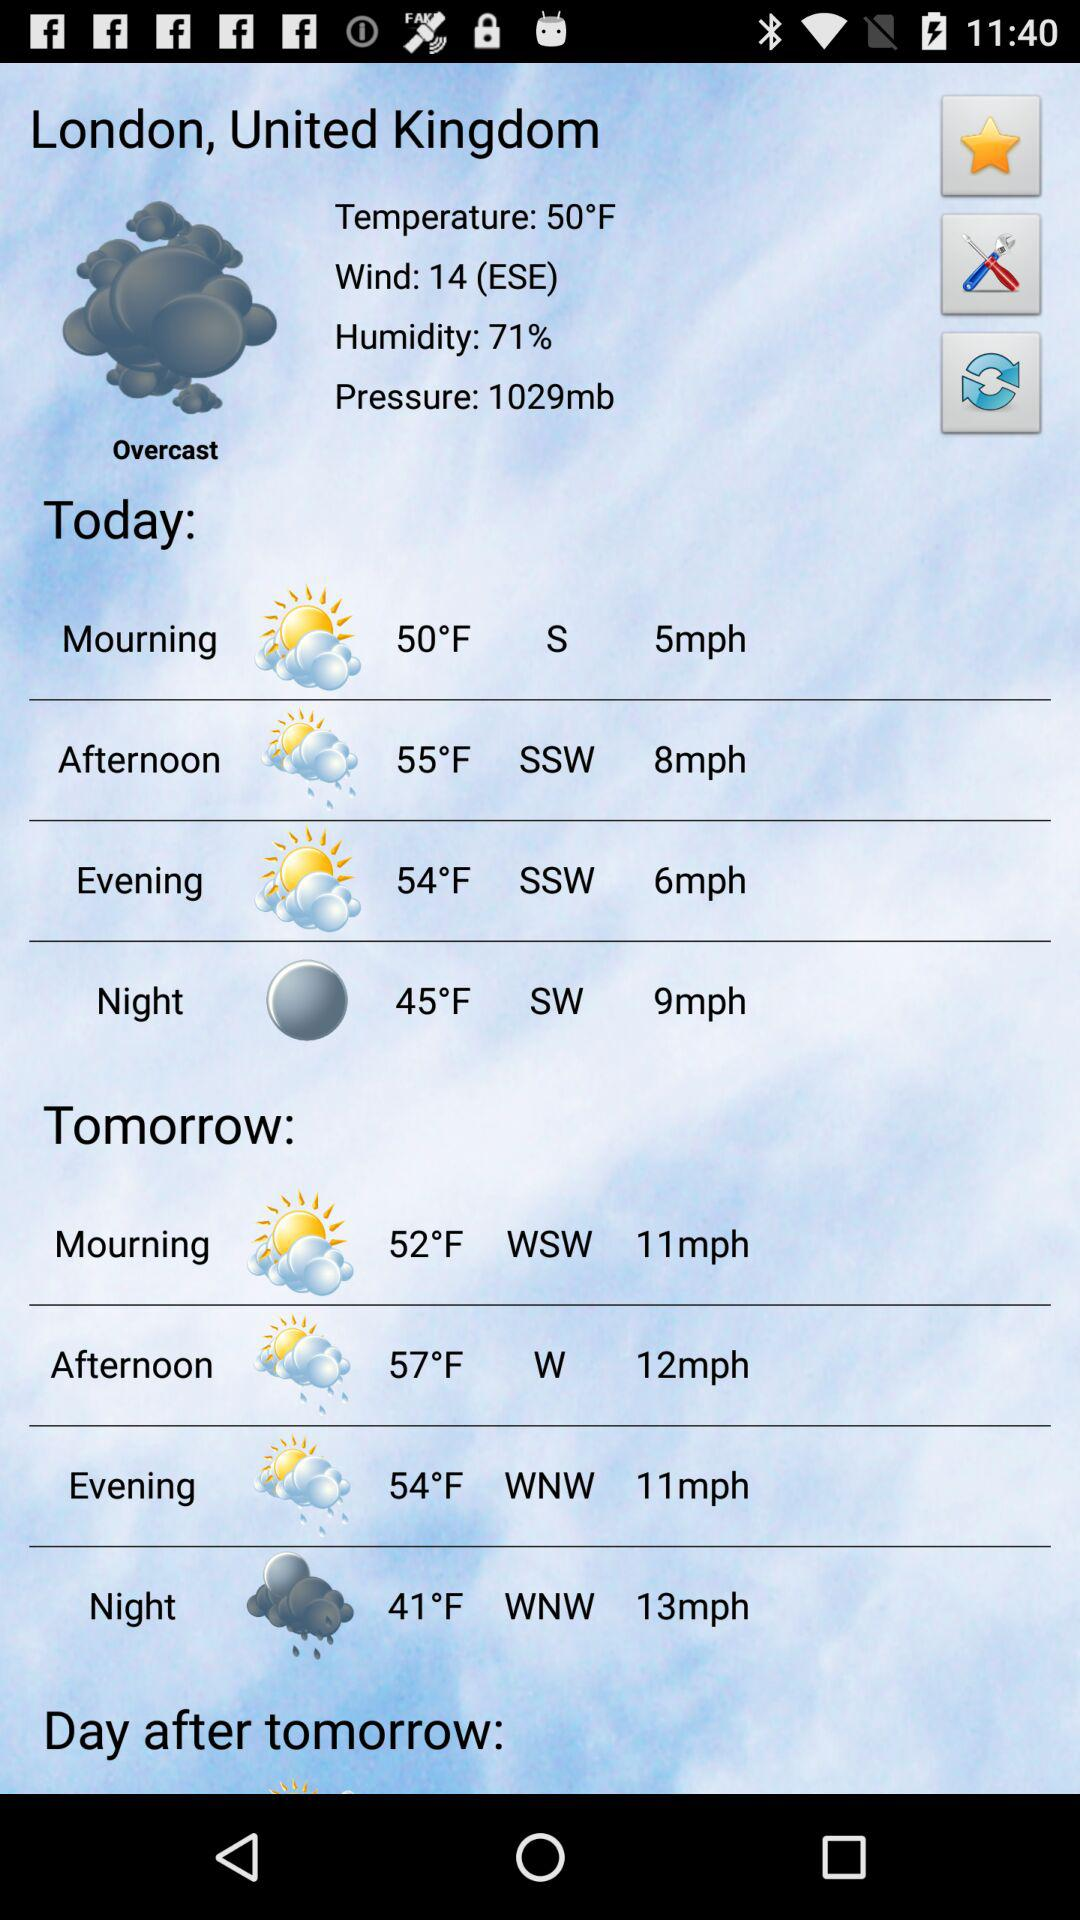What is the temperature like today in London, United Kingdom? Today's temperature in London, United Kingdom, is 50°F. 